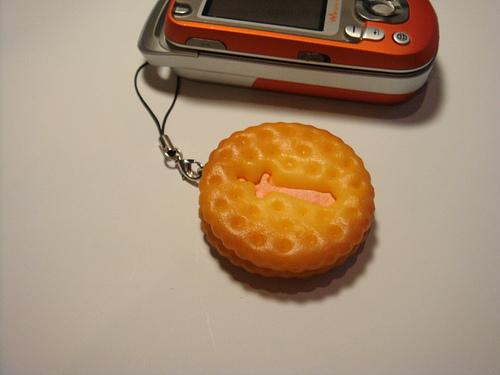Illustrate the key features of the image in one concise sentence. An orange and silver flip phone lies on a counter with a chain-linked cookie charm attached. Mention the primary subject matter of the image with an emphasis on their interaction. A silver flip phone, featuring an orange accent, is laying on a table with a circular cookie charm attached to it through a metal chain. Narrate the most prominent element of the image. An orange and silver cell phone with a plastic cookie charm on a chain, resting on a surface showcasing camera buttons. Provide a brief overview of the scene depicted in the image. An orange and silver flip phone with a charm resembling a cookie attached via a chain is placed on a counter with the camera buttons visible. Characterize the main focus of the image along with a visual detail. An orange and silver flip phone, featuring a camera, is accessorized with a cookie-shaped charm that's attached using a chain. Compose a summary of the picture's primary subject and their surrounding context. A silver and orange cell phone rests on a counter, accompanied by a chain-bound plastic charm resembling a circular cookie. Give an overview of the main components in the image and their arrangement. A counter holding an orange and silver cell phone with a camera, adorned by a cookie-shaped charm on a chain connected to the device. Describe the setting of the image with a focus on the main object. A flip phone, in hues of orange and silver, is displayed on a counter, adorned with a charming cookie-shaped keychain. Indicate the central object of the image and its notable features. A flip phone with orange accents, silver casing, and a camera, adorned with a chained, plastic, circular cookie charm. Express the subject matter of the image, emphasizing on its most visible attributes. An appealing and captivating image of an orange and silver flip phone features a camera and showcases a delightful cookie charm hanging on a chain. 